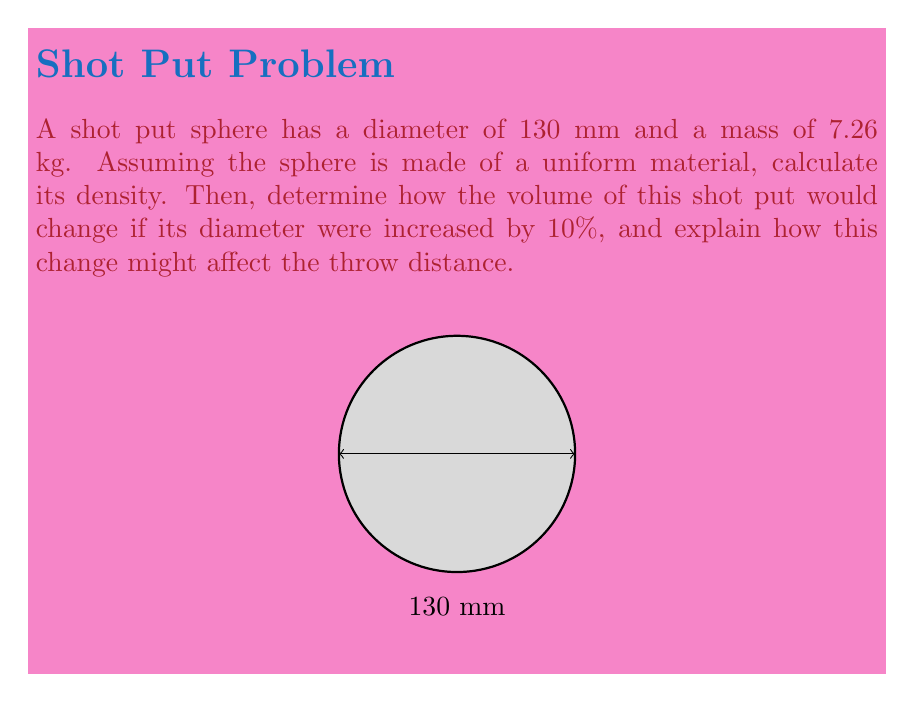What is the answer to this math problem? Let's approach this problem step-by-step:

1) First, we need to calculate the volume of the shot put:
   Volume of a sphere: $V = \frac{4}{3}\pi r^3$
   Radius $r = 65$ mm $= 0.065$ m
   $V = \frac{4}{3}\pi (0.065)^3 = 0.001150795$ m³

2) Now we can calculate the density:
   Density $\rho = \frac{\text{mass}}{\text{volume}} = \frac{7.26}{0.001150795} = 6308.4$ kg/m³

3) If the diameter increases by 10%, the new diameter would be:
   $130 \text{ mm} \times 1.10 = 143 \text{ mm}$
   New radius $= 71.5 \text{ mm} = 0.0715 \text{ m}$

4) The new volume would be:
   $V_{\text{new}} = \frac{4}{3}\pi (0.0715)^3 = 0.001527064$ m³

5) The volume increase is:
   $\frac{0.001527064 - 0.001150795}{0.001150795} \times 100\% = 32.7\%$

6) Impact on throw distance:
   The increased volume would lead to a larger surface area, potentially increasing air resistance. However, if the mass remains constant, the density would decrease, which could affect the ball's momentum and energy transfer during the throw. The exact impact on throw distance would depend on various factors, including the thrower's technique and strength, but generally, a larger volume with the same mass might lead to slightly shorter throws due to increased air resistance.
Answer: Density: 6308.4 kg/m³; Volume increase: 32.7%; Likely shorter throw distance due to increased air resistance. 